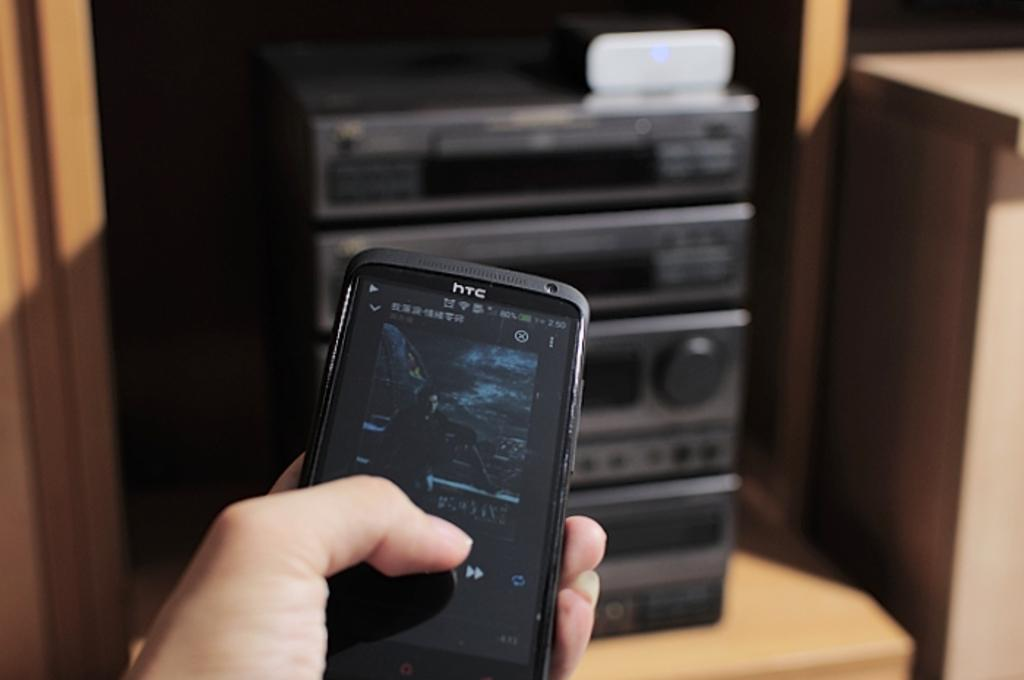What object is the person holding in the image? The person is holding a HTC mobile phone in the image. What can be seen in the background of the image? There is a home theatre on a wooden surface in the background of the image. What type of comb is being used to fix the error in the image? There is no comb or error present in the image. 